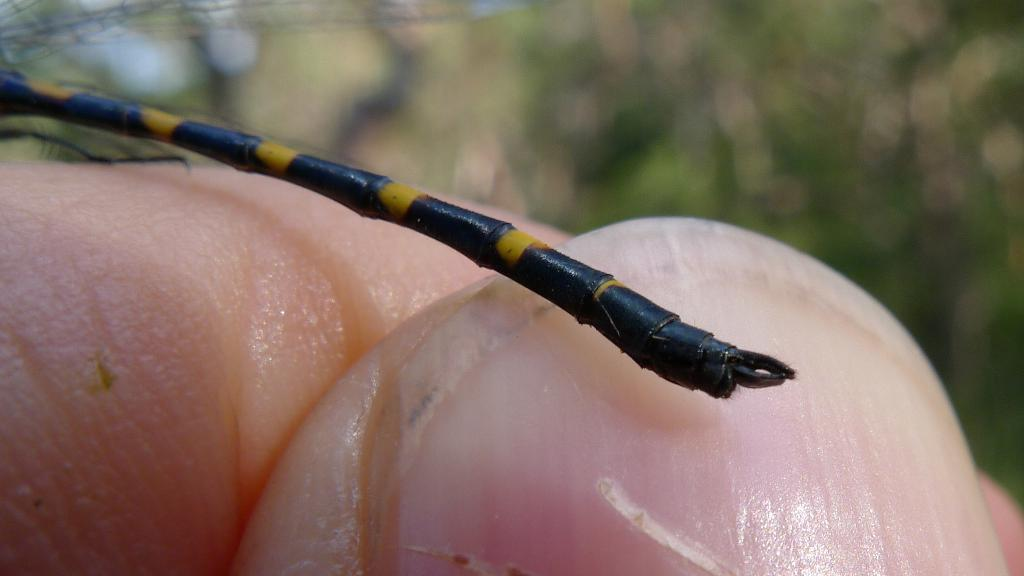What is the focus of the image? The image is zoomed in, and there are fingers of a person in the foreground. What else can be seen in the image besides the fingers? There appears to be an insect in the image. How would you describe the background of the image? The background of the image is blurry. What type of nail is being used by the person in the image? There is no nail visible in the image; only fingers and an insect are present. What game is being played in the background of the image? There is no game being played in the image; the background is blurry and does not show any specific activity. 